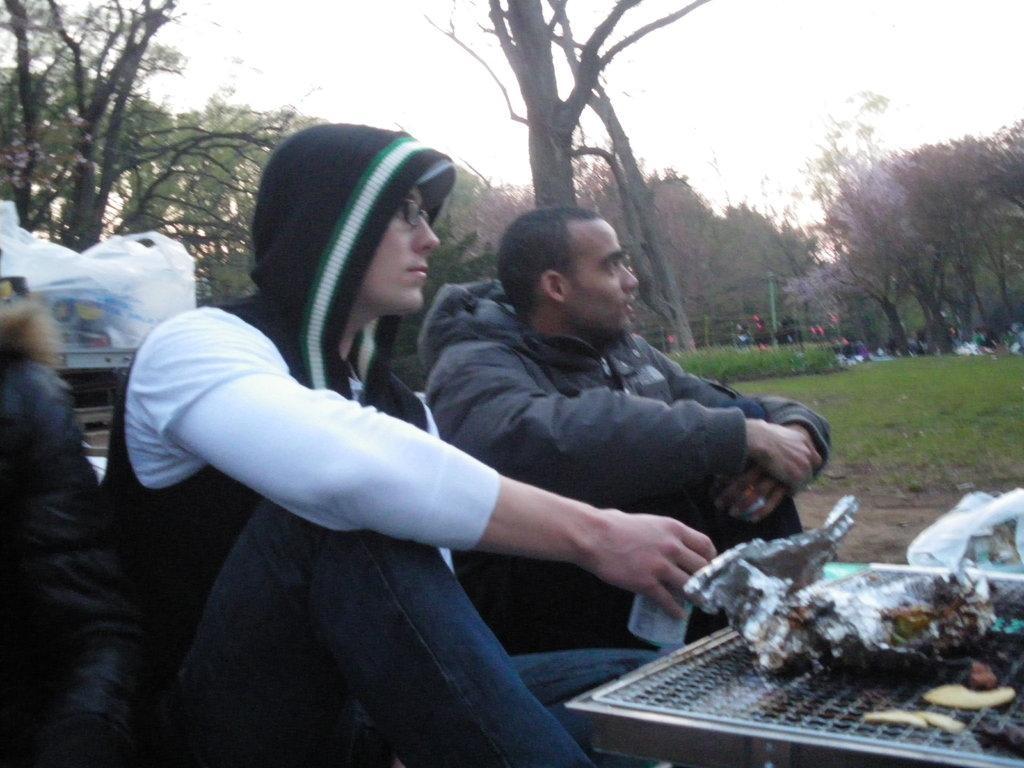In one or two sentences, can you explain what this image depicts? In this image in the foreground there are two persons who are sitting, in front of them there is one board. On the board there is some cover and some food, on the left side there is another person who is sitting and in the background there are some plastic covers trees and some persons and grass. At the top of the image there is sky. 